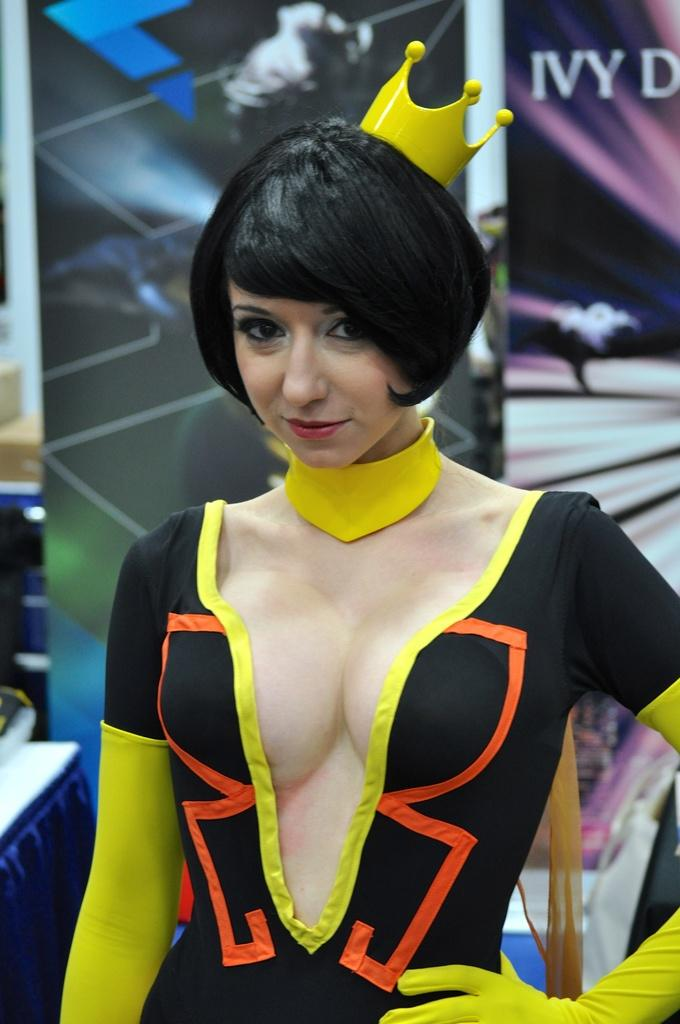<image>
Render a clear and concise summary of the photo. Woman wearing a costume in front of an ad that says IVY. 